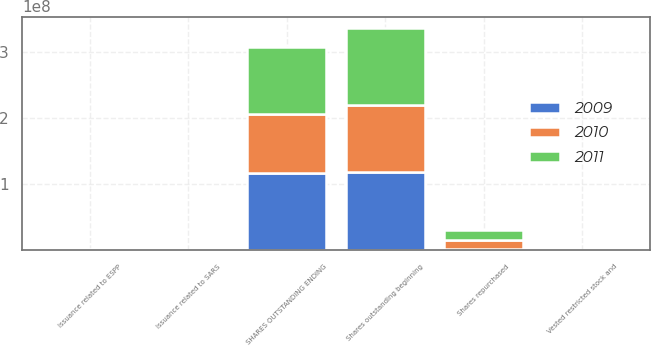<chart> <loc_0><loc_0><loc_500><loc_500><stacked_bar_chart><ecel><fcel>Shares outstanding beginning<fcel>Vested restricted stock and<fcel>Issuance related to ESPP<fcel>Issuance related to SARS<fcel>Shares repurchased<fcel>SHARES OUTSTANDING ENDING<nl><fcel>2010<fcel>1.02e+08<fcel>336919<fcel>217787<fcel>57837<fcel>1.40885e+07<fcel>8.85244e+07<nl><fcel>2011<fcel>1.16649e+08<fcel>227094<fcel>324162<fcel>25046<fcel>1.52246e+07<fcel>1.02e+08<nl><fcel>2009<fcel>1.17369e+08<fcel>78826<fcel>321038<fcel>2366<fcel>1.12205e+06<fcel>1.16649e+08<nl></chart> 